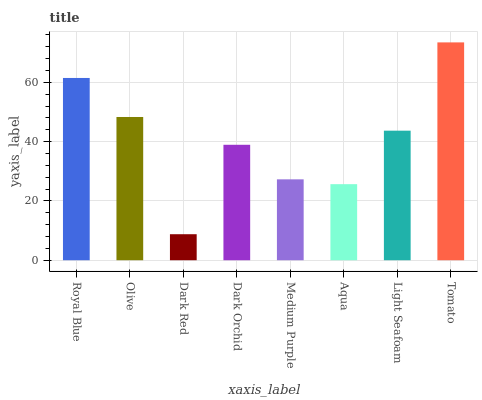Is Dark Red the minimum?
Answer yes or no. Yes. Is Tomato the maximum?
Answer yes or no. Yes. Is Olive the minimum?
Answer yes or no. No. Is Olive the maximum?
Answer yes or no. No. Is Royal Blue greater than Olive?
Answer yes or no. Yes. Is Olive less than Royal Blue?
Answer yes or no. Yes. Is Olive greater than Royal Blue?
Answer yes or no. No. Is Royal Blue less than Olive?
Answer yes or no. No. Is Light Seafoam the high median?
Answer yes or no. Yes. Is Dark Orchid the low median?
Answer yes or no. Yes. Is Olive the high median?
Answer yes or no. No. Is Tomato the low median?
Answer yes or no. No. 